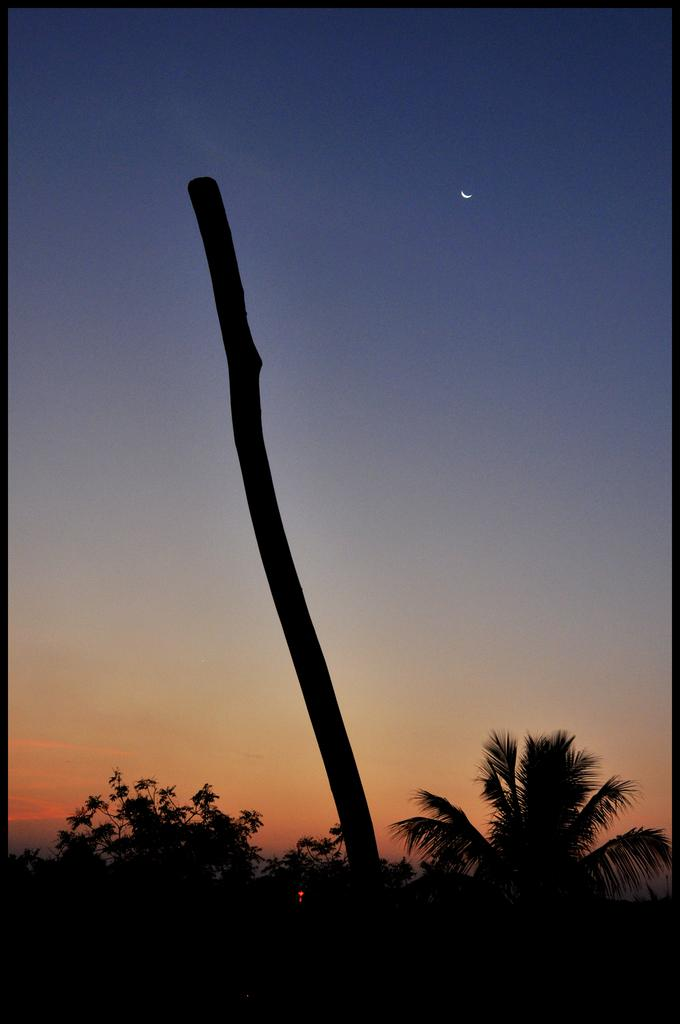What is the main object in the image? There is a pole in the image. What can be seen at the bottom of the image? Trees are visible at the bottom of the image. What is visible in the background of the image? The sky is visible in the background of the image. What specific feature can be seen in the sky? A half moon is present in the sky. How are the edges of the image defined? The image has black color borders. What type of tail does the uncle have in the image? There is no uncle present in the image, and therefore no tail to describe. 